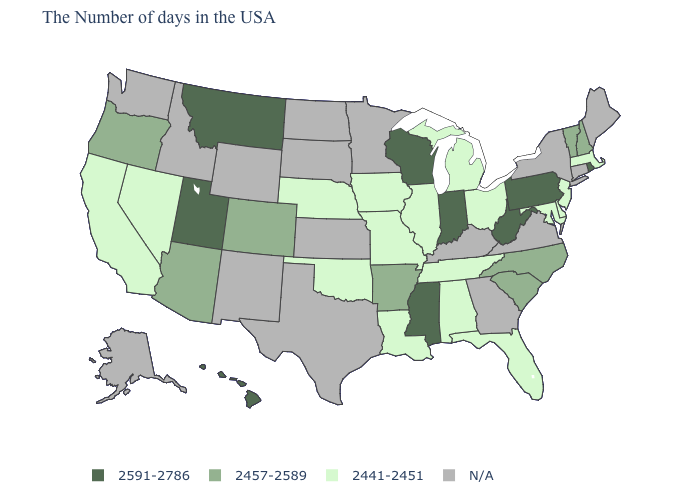How many symbols are there in the legend?
Keep it brief. 4. What is the lowest value in the MidWest?
Be succinct. 2441-2451. What is the value of Minnesota?
Concise answer only. N/A. What is the value of Kansas?
Keep it brief. N/A. What is the value of Oklahoma?
Give a very brief answer. 2441-2451. Among the states that border Maryland , does Delaware have the highest value?
Write a very short answer. No. What is the highest value in the MidWest ?
Quick response, please. 2591-2786. Does Montana have the highest value in the USA?
Answer briefly. Yes. Which states have the lowest value in the MidWest?
Answer briefly. Ohio, Michigan, Illinois, Missouri, Iowa, Nebraska. Name the states that have a value in the range 2457-2589?
Write a very short answer. New Hampshire, Vermont, North Carolina, South Carolina, Arkansas, Colorado, Arizona, Oregon. Name the states that have a value in the range 2441-2451?
Short answer required. Massachusetts, New Jersey, Delaware, Maryland, Ohio, Florida, Michigan, Alabama, Tennessee, Illinois, Louisiana, Missouri, Iowa, Nebraska, Oklahoma, Nevada, California. Name the states that have a value in the range 2457-2589?
Keep it brief. New Hampshire, Vermont, North Carolina, South Carolina, Arkansas, Colorado, Arizona, Oregon. Does Rhode Island have the highest value in the USA?
Answer briefly. Yes. 